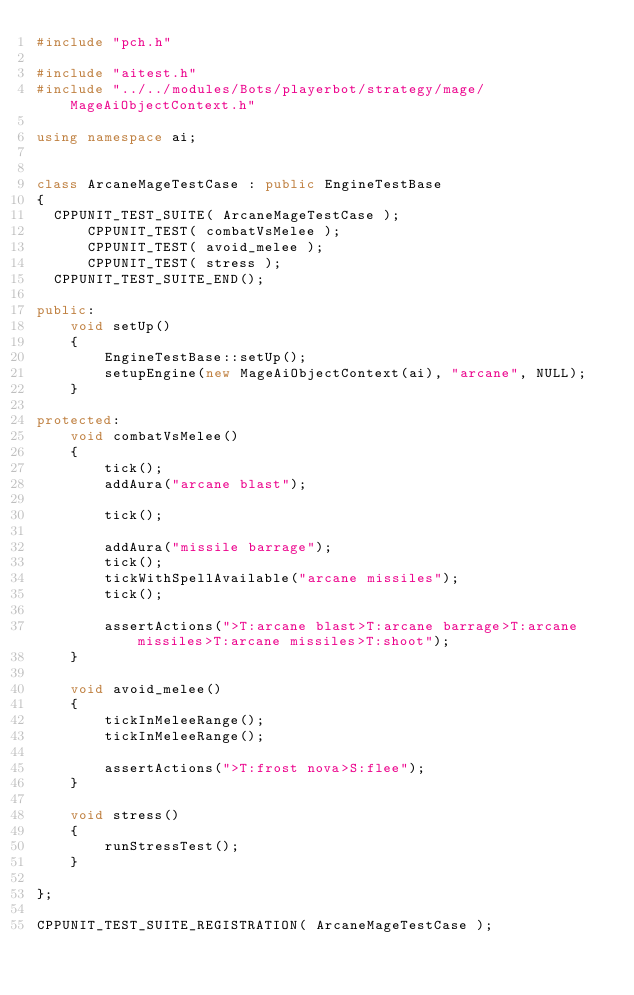Convert code to text. <code><loc_0><loc_0><loc_500><loc_500><_C++_>#include "pch.h"

#include "aitest.h"
#include "../../modules/Bots/playerbot/strategy/mage/MageAiObjectContext.h"

using namespace ai;


class ArcaneMageTestCase : public EngineTestBase
{
  CPPUNIT_TEST_SUITE( ArcaneMageTestCase );
      CPPUNIT_TEST( combatVsMelee );
      CPPUNIT_TEST( avoid_melee );
      CPPUNIT_TEST( stress );
  CPPUNIT_TEST_SUITE_END();

public:
    void setUp()
    {
		EngineTestBase::setUp();
		setupEngine(new MageAiObjectContext(ai), "arcane", NULL);
    }

protected:
 	void combatVsMelee()
	{
        tick();
		addAura("arcane blast");

        tick();

        addAura("missile barrage");
        tick();
        tickWithSpellAvailable("arcane missiles");
        tick();

        assertActions(">T:arcane blast>T:arcane barrage>T:arcane missiles>T:arcane missiles>T:shoot");
	}

 	void avoid_melee()
 	{
		tickInMeleeRange();
		tickInMeleeRange();

		assertActions(">T:frost nova>S:flee");
	}

    void stress()
    {
        runStressTest();
    }

};

CPPUNIT_TEST_SUITE_REGISTRATION( ArcaneMageTestCase );
</code> 